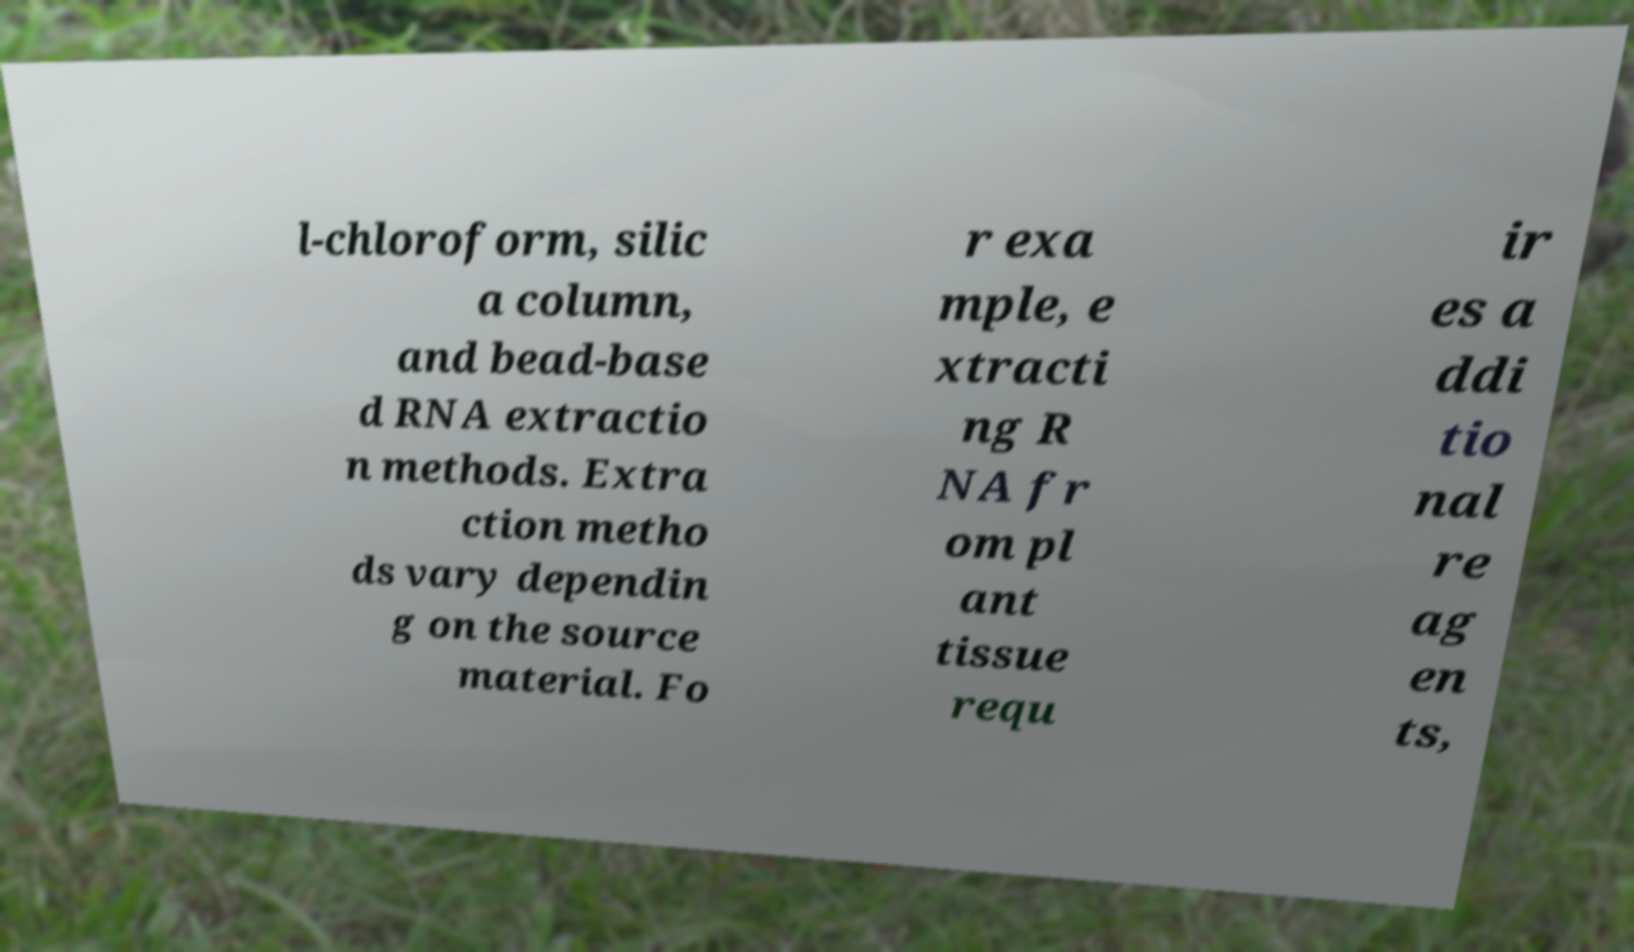Can you read and provide the text displayed in the image?This photo seems to have some interesting text. Can you extract and type it out for me? l-chloroform, silic a column, and bead-base d RNA extractio n methods. Extra ction metho ds vary dependin g on the source material. Fo r exa mple, e xtracti ng R NA fr om pl ant tissue requ ir es a ddi tio nal re ag en ts, 